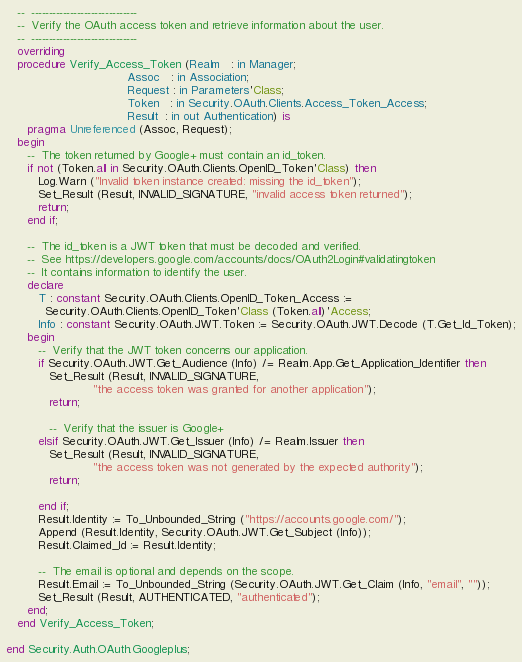Convert code to text. <code><loc_0><loc_0><loc_500><loc_500><_Ada_>   --  ------------------------------
   --  Verify the OAuth access token and retrieve information about the user.
   --  ------------------------------
   overriding
   procedure Verify_Access_Token (Realm   : in Manager;
                                  Assoc   : in Association;
                                  Request : in Parameters'Class;
                                  Token   : in Security.OAuth.Clients.Access_Token_Access;
                                  Result  : in out Authentication) is
      pragma Unreferenced (Assoc, Request);
   begin
      --  The token returned by Google+ must contain an id_token.
      if not (Token.all in Security.OAuth.Clients.OpenID_Token'Class) then
         Log.Warn ("Invalid token instance created: missing the id_token");
         Set_Result (Result, INVALID_SIGNATURE, "invalid access token returned");
         return;
      end if;

      --  The id_token is a JWT token that must be decoded and verified.
      --  See https://developers.google.com/accounts/docs/OAuth2Login#validatingtoken
      --  It contains information to identify the user.
      declare
         T : constant Security.OAuth.Clients.OpenID_Token_Access :=
           Security.OAuth.Clients.OpenID_Token'Class (Token.all)'Access;
         Info : constant Security.OAuth.JWT.Token := Security.OAuth.JWT.Decode (T.Get_Id_Token);
      begin
         --  Verify that the JWT token concerns our application.
         if Security.OAuth.JWT.Get_Audience (Info) /= Realm.App.Get_Application_Identifier then
            Set_Result (Result, INVALID_SIGNATURE,
                        "the access token was granted for another application");
            return;

            --  Verify that the issuer is Google+
         elsif Security.OAuth.JWT.Get_Issuer (Info) /= Realm.Issuer then
            Set_Result (Result, INVALID_SIGNATURE,
                        "the access token was not generated by the expected authority");
            return;

         end if;
         Result.Identity := To_Unbounded_String ("https://accounts.google.com/");
         Append (Result.Identity, Security.OAuth.JWT.Get_Subject (Info));
         Result.Claimed_Id := Result.Identity;

         --  The email is optional and depends on the scope.
         Result.Email := To_Unbounded_String (Security.OAuth.JWT.Get_Claim (Info, "email", ""));
         Set_Result (Result, AUTHENTICATED, "authenticated");
      end;
   end Verify_Access_Token;

end Security.Auth.OAuth.Googleplus;
</code> 